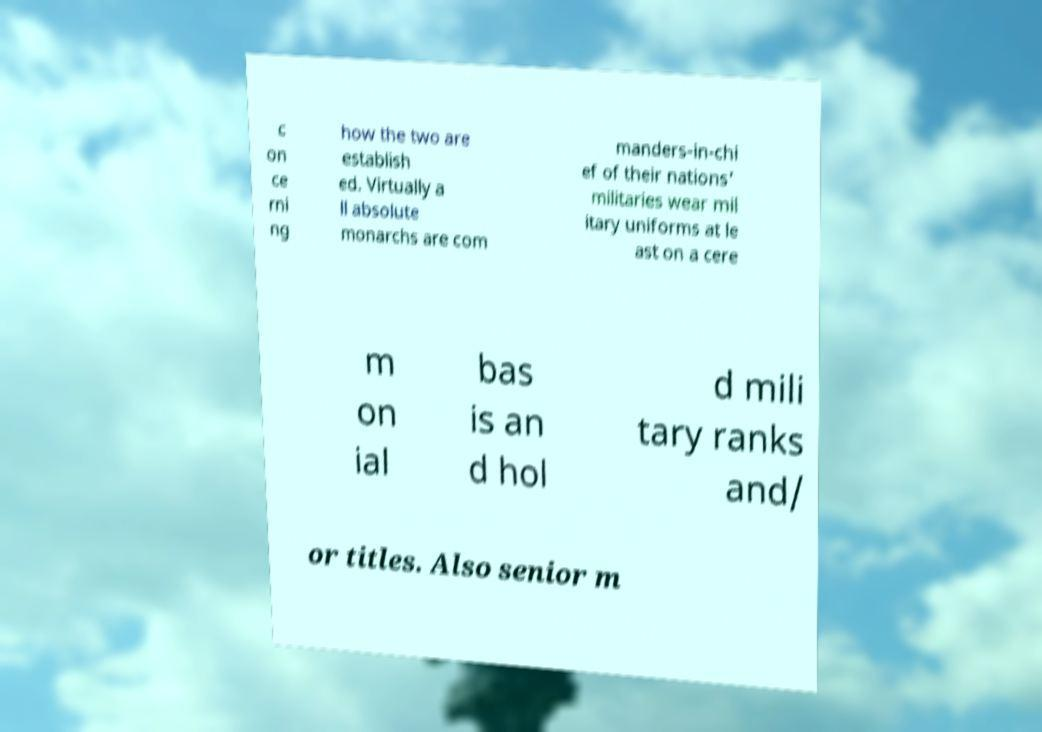Can you read and provide the text displayed in the image?This photo seems to have some interesting text. Can you extract and type it out for me? c on ce rni ng how the two are establish ed. Virtually a ll absolute monarchs are com manders-in-chi ef of their nations' militaries wear mil itary uniforms at le ast on a cere m on ial bas is an d hol d mili tary ranks and/ or titles. Also senior m 